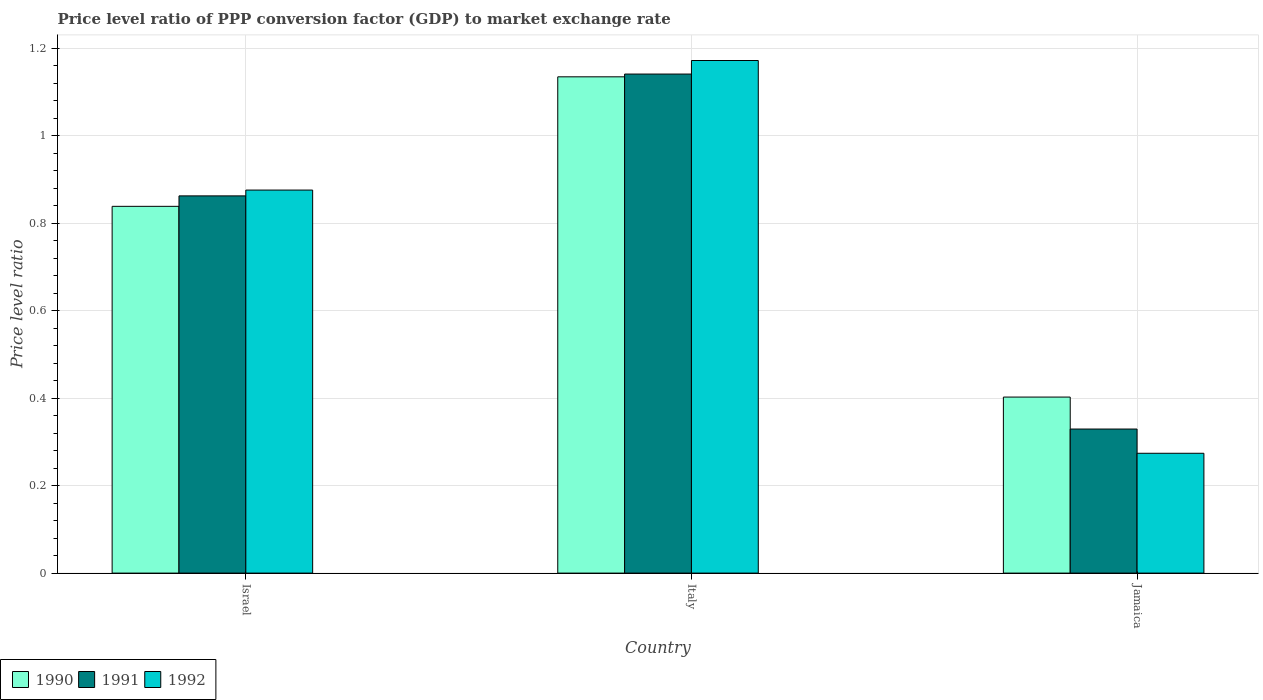How many different coloured bars are there?
Your answer should be compact. 3. How many groups of bars are there?
Provide a succinct answer. 3. Are the number of bars per tick equal to the number of legend labels?
Keep it short and to the point. Yes. How many bars are there on the 1st tick from the left?
Your answer should be compact. 3. How many bars are there on the 1st tick from the right?
Keep it short and to the point. 3. What is the price level ratio in 1990 in Italy?
Ensure brevity in your answer.  1.13. Across all countries, what is the maximum price level ratio in 1992?
Your response must be concise. 1.17. Across all countries, what is the minimum price level ratio in 1991?
Your answer should be compact. 0.33. In which country was the price level ratio in 1992 maximum?
Provide a short and direct response. Italy. In which country was the price level ratio in 1990 minimum?
Provide a succinct answer. Jamaica. What is the total price level ratio in 1991 in the graph?
Offer a terse response. 2.33. What is the difference between the price level ratio in 1992 in Israel and that in Italy?
Your response must be concise. -0.3. What is the difference between the price level ratio in 1991 in Italy and the price level ratio in 1992 in Jamaica?
Ensure brevity in your answer.  0.87. What is the average price level ratio in 1990 per country?
Provide a short and direct response. 0.79. What is the difference between the price level ratio of/in 1991 and price level ratio of/in 1990 in Israel?
Make the answer very short. 0.02. In how many countries, is the price level ratio in 1992 greater than 0.48000000000000004?
Keep it short and to the point. 2. What is the ratio of the price level ratio in 1992 in Italy to that in Jamaica?
Make the answer very short. 4.28. What is the difference between the highest and the second highest price level ratio in 1990?
Offer a terse response. -0.3. What is the difference between the highest and the lowest price level ratio in 1990?
Your answer should be very brief. 0.73. In how many countries, is the price level ratio in 1992 greater than the average price level ratio in 1992 taken over all countries?
Provide a short and direct response. 2. How many bars are there?
Provide a short and direct response. 9. Are all the bars in the graph horizontal?
Your response must be concise. No. What is the difference between two consecutive major ticks on the Y-axis?
Offer a terse response. 0.2. Where does the legend appear in the graph?
Your answer should be very brief. Bottom left. How many legend labels are there?
Make the answer very short. 3. How are the legend labels stacked?
Give a very brief answer. Horizontal. What is the title of the graph?
Provide a succinct answer. Price level ratio of PPP conversion factor (GDP) to market exchange rate. Does "1970" appear as one of the legend labels in the graph?
Keep it short and to the point. No. What is the label or title of the Y-axis?
Make the answer very short. Price level ratio. What is the Price level ratio of 1990 in Israel?
Your answer should be compact. 0.84. What is the Price level ratio in 1991 in Israel?
Ensure brevity in your answer.  0.86. What is the Price level ratio in 1992 in Israel?
Offer a very short reply. 0.88. What is the Price level ratio of 1990 in Italy?
Keep it short and to the point. 1.13. What is the Price level ratio of 1991 in Italy?
Your response must be concise. 1.14. What is the Price level ratio in 1992 in Italy?
Your answer should be compact. 1.17. What is the Price level ratio in 1990 in Jamaica?
Provide a short and direct response. 0.4. What is the Price level ratio in 1991 in Jamaica?
Ensure brevity in your answer.  0.33. What is the Price level ratio in 1992 in Jamaica?
Offer a very short reply. 0.27. Across all countries, what is the maximum Price level ratio of 1990?
Your response must be concise. 1.13. Across all countries, what is the maximum Price level ratio of 1991?
Provide a short and direct response. 1.14. Across all countries, what is the maximum Price level ratio of 1992?
Provide a succinct answer. 1.17. Across all countries, what is the minimum Price level ratio in 1990?
Provide a succinct answer. 0.4. Across all countries, what is the minimum Price level ratio of 1991?
Your response must be concise. 0.33. Across all countries, what is the minimum Price level ratio of 1992?
Offer a terse response. 0.27. What is the total Price level ratio of 1990 in the graph?
Provide a succinct answer. 2.38. What is the total Price level ratio of 1991 in the graph?
Offer a terse response. 2.33. What is the total Price level ratio of 1992 in the graph?
Your answer should be compact. 2.32. What is the difference between the Price level ratio in 1990 in Israel and that in Italy?
Make the answer very short. -0.3. What is the difference between the Price level ratio of 1991 in Israel and that in Italy?
Give a very brief answer. -0.28. What is the difference between the Price level ratio of 1992 in Israel and that in Italy?
Give a very brief answer. -0.3. What is the difference between the Price level ratio in 1990 in Israel and that in Jamaica?
Give a very brief answer. 0.44. What is the difference between the Price level ratio of 1991 in Israel and that in Jamaica?
Offer a very short reply. 0.53. What is the difference between the Price level ratio in 1992 in Israel and that in Jamaica?
Your response must be concise. 0.6. What is the difference between the Price level ratio in 1990 in Italy and that in Jamaica?
Offer a very short reply. 0.73. What is the difference between the Price level ratio in 1991 in Italy and that in Jamaica?
Offer a terse response. 0.81. What is the difference between the Price level ratio in 1992 in Italy and that in Jamaica?
Make the answer very short. 0.9. What is the difference between the Price level ratio of 1990 in Israel and the Price level ratio of 1991 in Italy?
Offer a very short reply. -0.3. What is the difference between the Price level ratio of 1990 in Israel and the Price level ratio of 1992 in Italy?
Ensure brevity in your answer.  -0.33. What is the difference between the Price level ratio in 1991 in Israel and the Price level ratio in 1992 in Italy?
Provide a succinct answer. -0.31. What is the difference between the Price level ratio of 1990 in Israel and the Price level ratio of 1991 in Jamaica?
Provide a short and direct response. 0.51. What is the difference between the Price level ratio of 1990 in Israel and the Price level ratio of 1992 in Jamaica?
Your answer should be compact. 0.56. What is the difference between the Price level ratio in 1991 in Israel and the Price level ratio in 1992 in Jamaica?
Ensure brevity in your answer.  0.59. What is the difference between the Price level ratio of 1990 in Italy and the Price level ratio of 1991 in Jamaica?
Provide a short and direct response. 0.81. What is the difference between the Price level ratio of 1990 in Italy and the Price level ratio of 1992 in Jamaica?
Keep it short and to the point. 0.86. What is the difference between the Price level ratio in 1991 in Italy and the Price level ratio in 1992 in Jamaica?
Ensure brevity in your answer.  0.87. What is the average Price level ratio in 1990 per country?
Offer a very short reply. 0.79. What is the average Price level ratio of 1991 per country?
Offer a very short reply. 0.78. What is the average Price level ratio in 1992 per country?
Your answer should be compact. 0.77. What is the difference between the Price level ratio of 1990 and Price level ratio of 1991 in Israel?
Provide a short and direct response. -0.02. What is the difference between the Price level ratio in 1990 and Price level ratio in 1992 in Israel?
Offer a very short reply. -0.04. What is the difference between the Price level ratio of 1991 and Price level ratio of 1992 in Israel?
Provide a short and direct response. -0.01. What is the difference between the Price level ratio in 1990 and Price level ratio in 1991 in Italy?
Your answer should be compact. -0.01. What is the difference between the Price level ratio in 1990 and Price level ratio in 1992 in Italy?
Provide a succinct answer. -0.04. What is the difference between the Price level ratio of 1991 and Price level ratio of 1992 in Italy?
Provide a short and direct response. -0.03. What is the difference between the Price level ratio of 1990 and Price level ratio of 1991 in Jamaica?
Your response must be concise. 0.07. What is the difference between the Price level ratio of 1990 and Price level ratio of 1992 in Jamaica?
Your response must be concise. 0.13. What is the difference between the Price level ratio in 1991 and Price level ratio in 1992 in Jamaica?
Give a very brief answer. 0.06. What is the ratio of the Price level ratio in 1990 in Israel to that in Italy?
Your response must be concise. 0.74. What is the ratio of the Price level ratio in 1991 in Israel to that in Italy?
Offer a terse response. 0.76. What is the ratio of the Price level ratio of 1992 in Israel to that in Italy?
Make the answer very short. 0.75. What is the ratio of the Price level ratio in 1990 in Israel to that in Jamaica?
Give a very brief answer. 2.08. What is the ratio of the Price level ratio of 1991 in Israel to that in Jamaica?
Provide a short and direct response. 2.62. What is the ratio of the Price level ratio of 1992 in Israel to that in Jamaica?
Keep it short and to the point. 3.2. What is the ratio of the Price level ratio in 1990 in Italy to that in Jamaica?
Ensure brevity in your answer.  2.82. What is the ratio of the Price level ratio of 1991 in Italy to that in Jamaica?
Offer a very short reply. 3.46. What is the ratio of the Price level ratio of 1992 in Italy to that in Jamaica?
Your answer should be compact. 4.28. What is the difference between the highest and the second highest Price level ratio of 1990?
Keep it short and to the point. 0.3. What is the difference between the highest and the second highest Price level ratio in 1991?
Provide a succinct answer. 0.28. What is the difference between the highest and the second highest Price level ratio of 1992?
Provide a short and direct response. 0.3. What is the difference between the highest and the lowest Price level ratio in 1990?
Offer a terse response. 0.73. What is the difference between the highest and the lowest Price level ratio of 1991?
Give a very brief answer. 0.81. What is the difference between the highest and the lowest Price level ratio in 1992?
Provide a short and direct response. 0.9. 